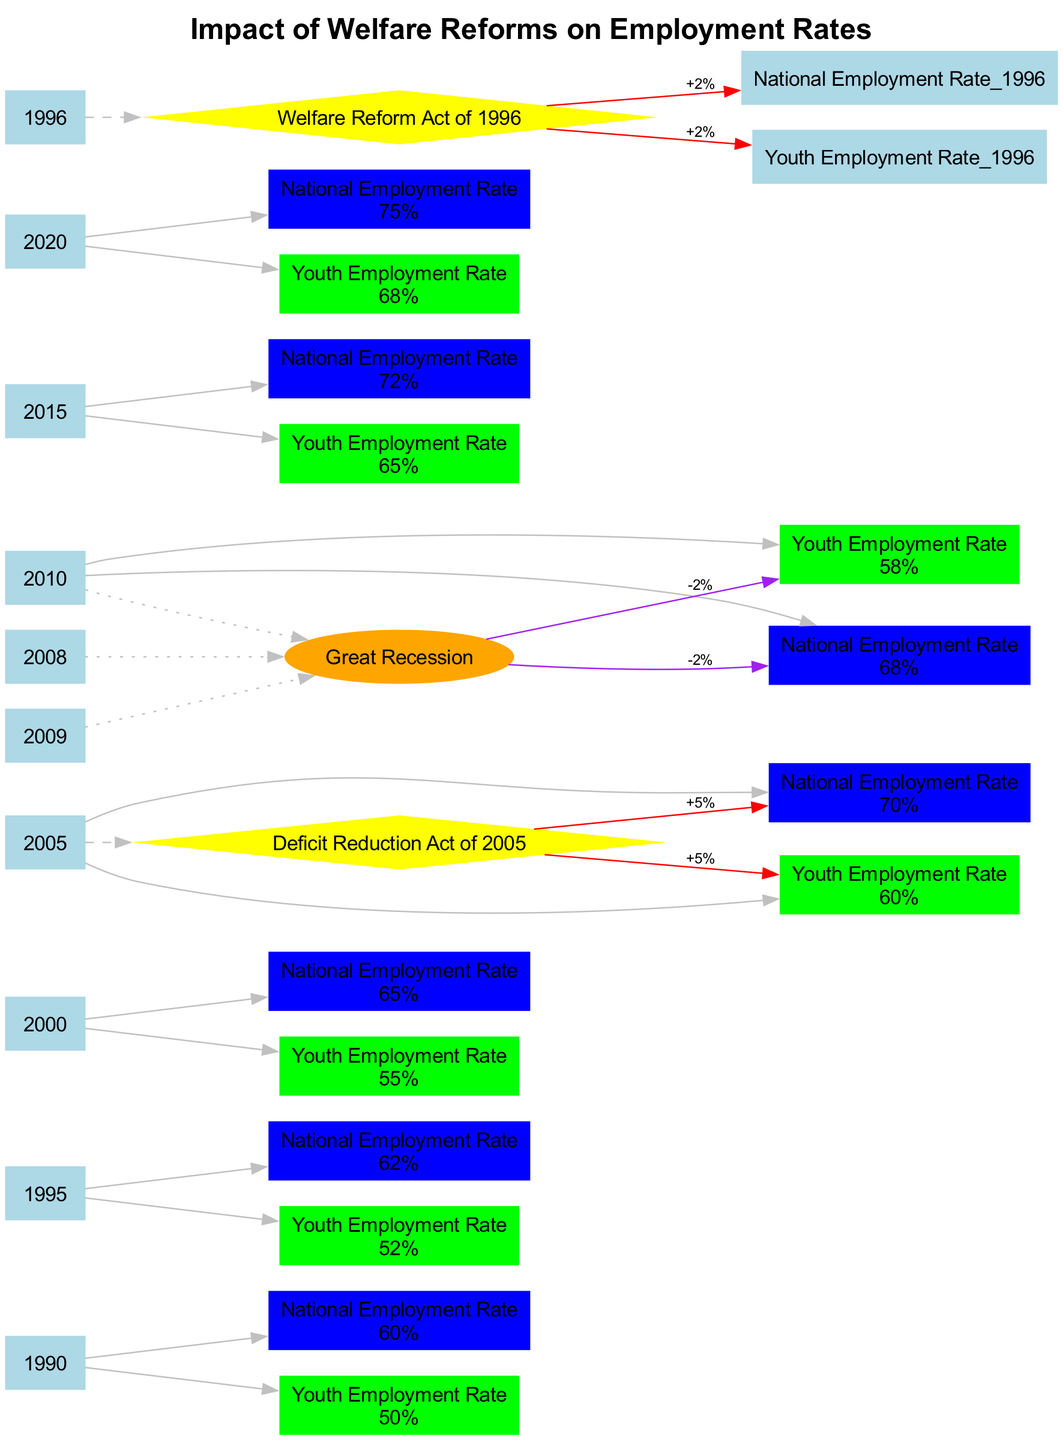What was the employment rate in 1990? Referring to the node for the year 1990 under the National Employment Rate, it shows a value of 60%.
Answer: 60% What year did the Welfare Reform Act occur? The diagram displays a dashed edge leading from the year 1996 to the node labeled "Welfare Reform Act of 1996".
Answer: 1996 How much did the National Employment Rate change after the Deficit Reduction Act of 2005? Analyzing the impact listed under the event node for the Deficit Reduction Act of 2005, it indicates a "+5%" change for the National Employment Rate.
Answer: +5% What was the National Employment Rate in 2005? The node corresponding to the year 2005 under the National Employment Rate shows a value of 70%.
Answer: 70% What was the impact of the Great Recession on Youth Employment Rates? The diagram includes a dotted entry from the Great Recession node to the Youth Employment Rate node indicating a "-2%" change.
Answer: -2% Which event caused an increase in both National and Youth Employment Rates by 2%? The dashed edge from the year 1996 leads to the event node labeled "Welfare Reform Act of 1996", indicating the impact of this event was a 2% increase for both employment rates.
Answer: Welfare Reform Act of 1996 How many years displayed an employment rate above 70%? By examining the nodes for each year, it can be observed that from 2005 to 2020, the employment rates (70%, 68%, 72%, 75%) indicate that there are three instances above 70% (2015, 2020).
Answer: 3 What was the employment rate for youth in 2010? Referring to the node for the year 2010 under Youth Employment Rate, it presents a value of 58%.
Answer: 58% What color represents the Youth Employment Rate in the diagram? Each series in the diagram is color-coded, and the Youth Employment Rate is represented by green color.
Answer: Green 